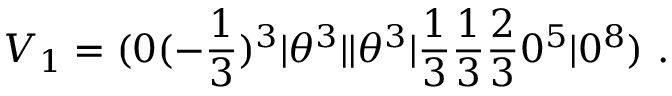<formula> <loc_0><loc_0><loc_500><loc_500>V _ { 1 } = ( 0 ( - { \frac { 1 } { 3 } } ) ^ { 3 } | \theta ^ { 3 } | | \theta ^ { 3 } | { \frac { 1 } { 3 } } { \frac { 1 } { 3 } } { \frac { 2 } { 3 } } 0 ^ { 5 } | 0 ^ { 8 } ) .</formula> 